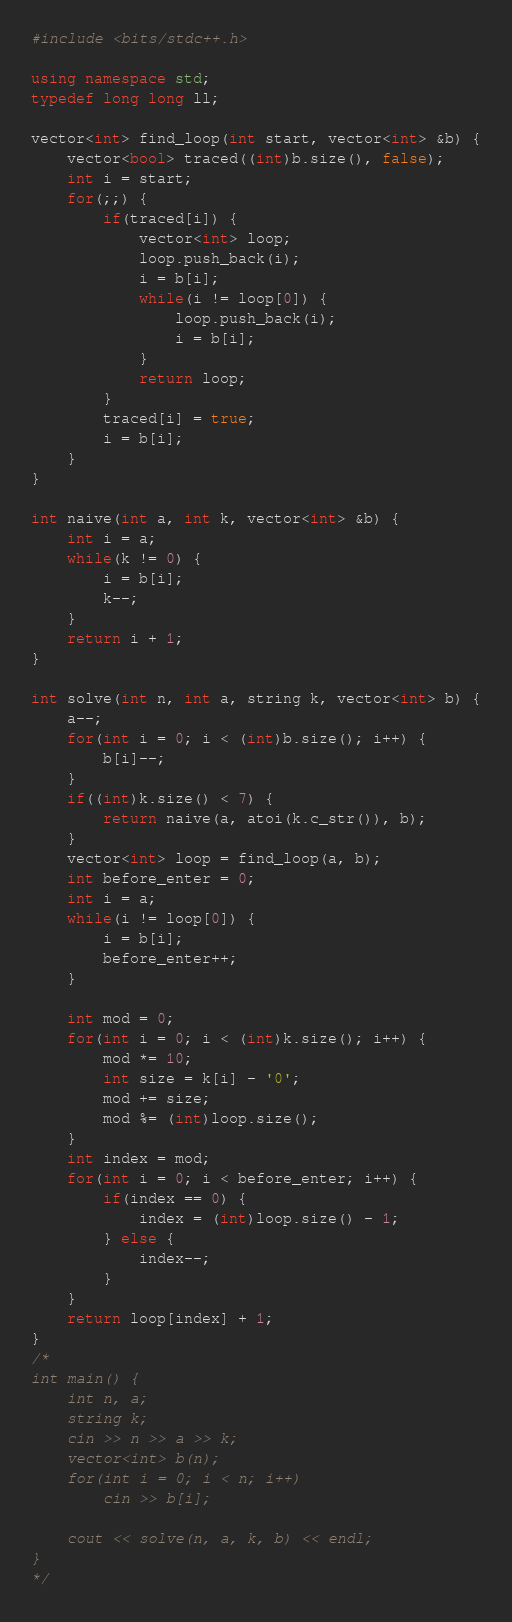<code> <loc_0><loc_0><loc_500><loc_500><_C++_>#include <bits/stdc++.h>

using namespace std;
typedef long long ll;

vector<int> find_loop(int start, vector<int> &b) {
    vector<bool> traced((int)b.size(), false);
    int i = start;
    for(;;) {
        if(traced[i]) {
            vector<int> loop;
            loop.push_back(i);
            i = b[i];
            while(i != loop[0]) {
                loop.push_back(i);
                i = b[i];
            }
            return loop;
        }
        traced[i] = true;
        i = b[i];
    }
}

int naive(int a, int k, vector<int> &b) {
    int i = a;
    while(k != 0) {
        i = b[i];
        k--;
    }
    return i + 1;
}

int solve(int n, int a, string k, vector<int> b) {
    a--;
    for(int i = 0; i < (int)b.size(); i++) {
        b[i]--;
    }
    if((int)k.size() < 7) {
        return naive(a, atoi(k.c_str()), b);
    }
    vector<int> loop = find_loop(a, b);
    int before_enter = 0;
    int i = a;
    while(i != loop[0]) {
        i = b[i];
        before_enter++;
    }

    int mod = 0;
    for(int i = 0; i < (int)k.size(); i++) {
        mod *= 10;
        int size = k[i] - '0';
        mod += size;
        mod %= (int)loop.size();
    }
    int index = mod;
    for(int i = 0; i < before_enter; i++) {
        if(index == 0) {
            index = (int)loop.size() - 1;
        } else {
            index--;
        }
    }
    return loop[index] + 1;
}
/*
int main() {
    int n, a;
    string k;
    cin >> n >> a >> k;
    vector<int> b(n);
    for(int i = 0; i < n; i++)
        cin >> b[i];

    cout << solve(n, a, k, b) << endl;
}
*/</code> 